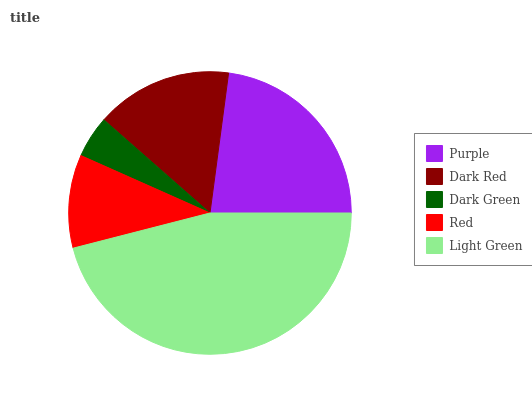Is Dark Green the minimum?
Answer yes or no. Yes. Is Light Green the maximum?
Answer yes or no. Yes. Is Dark Red the minimum?
Answer yes or no. No. Is Dark Red the maximum?
Answer yes or no. No. Is Purple greater than Dark Red?
Answer yes or no. Yes. Is Dark Red less than Purple?
Answer yes or no. Yes. Is Dark Red greater than Purple?
Answer yes or no. No. Is Purple less than Dark Red?
Answer yes or no. No. Is Dark Red the high median?
Answer yes or no. Yes. Is Dark Red the low median?
Answer yes or no. Yes. Is Dark Green the high median?
Answer yes or no. No. Is Purple the low median?
Answer yes or no. No. 